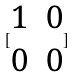<formula> <loc_0><loc_0><loc_500><loc_500>[ \begin{matrix} 1 & 0 \\ 0 & 0 \end{matrix} ]</formula> 